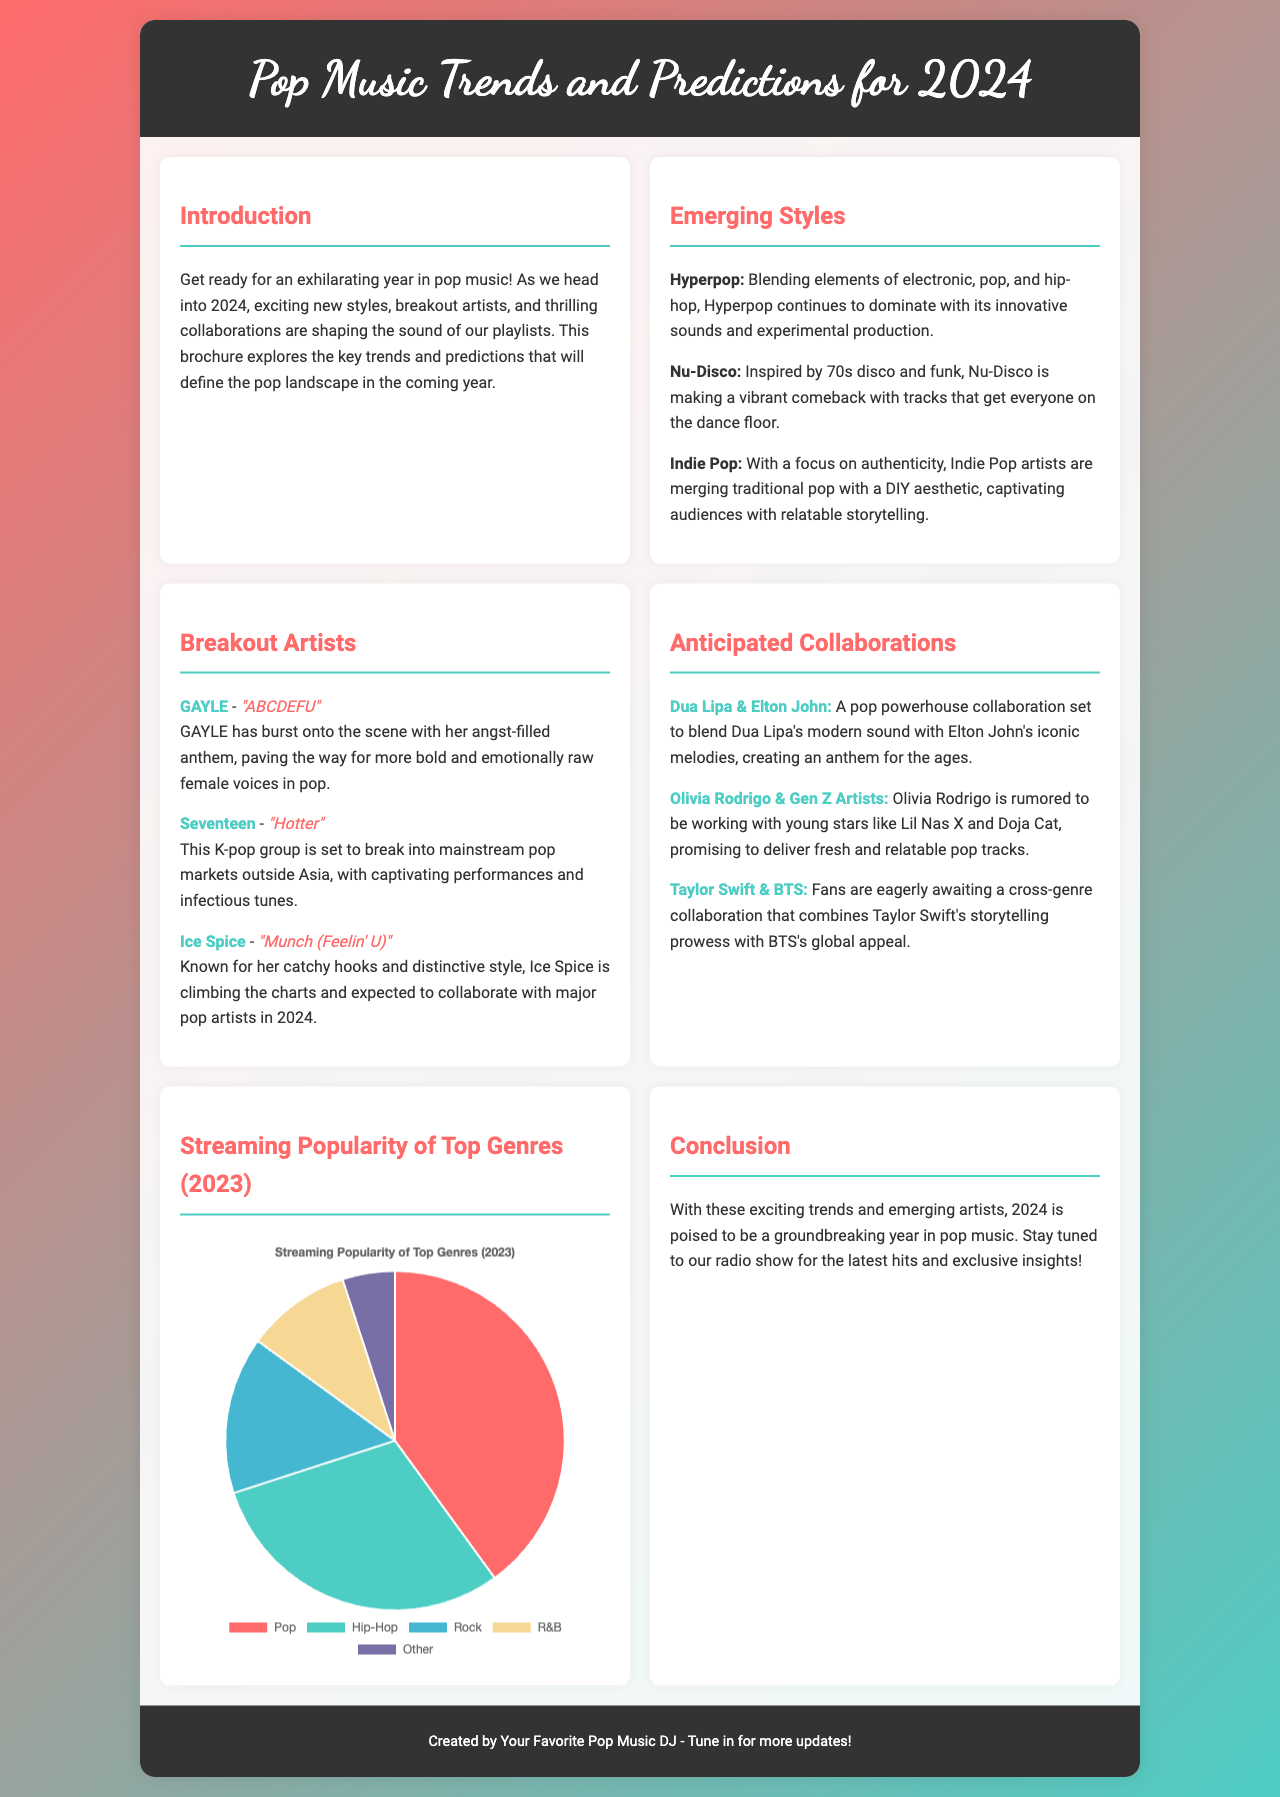What are the emerging styles in pop music for 2024? The brochure highlights three emerging styles that will define pop music in 2024: Hyperpop, Nu-Disco, and Indie Pop.
Answer: Hyperpop, Nu-Disco, Indie Pop Who is one of the breakout artists mentioned? The document lists several breakout artists; one of them is GAYLE, known for her hit song "ABCDEFU".
Answer: GAYLE What song is associated with Ice Spice? The brochure states that Ice Spice is known for her song "Munch (Feelin' U)".
Answer: "Munch (Feelin' U)" Which genre had the highest streaming popularity in 2023 according to the pie chart? The pie chart shows that Pop was the genre with the highest streaming popularity, making up 40% of the total.
Answer: Pop What collaboration is anticipated between Dua Lipa and Elton John? The document mentions a collaboration between Dua Lipa and Elton John that aims to blend their musical styles.
Answer: A pop powerhouse collaboration Which K-pop group is expected to break into mainstream pop? The brochure mentions that Seventeen is the K-pop group expected to break into mainstream pop markets outside Asia.
Answer: Seventeen What will Olivia Rodrigo's anticipated collaboration involve? Olivia Rodrigo is rumored to be collaborating with young stars like Lil Nas X and Doja Cat, focusing on fresh and relatable pop tracks.
Answer: Young stars like Lil Nas X and Doja Cat What is the purpose of the brochure? The brochure aims to explore key trends and predictions that will define the pop music landscape in 2024.
Answer: Explore pop music trends and predictions What is the visual representation used to show the streaming popularity of genres? The document uses a pie chart to represent the streaming popularity of different genres for 2023.
Answer: Pie chart Which color represents R&B in the streaming data chart? The pie chart's color scheme assigns a specific color to each genre, with R&B represented by the color '#f7d794'.
Answer: '#f7d794' 